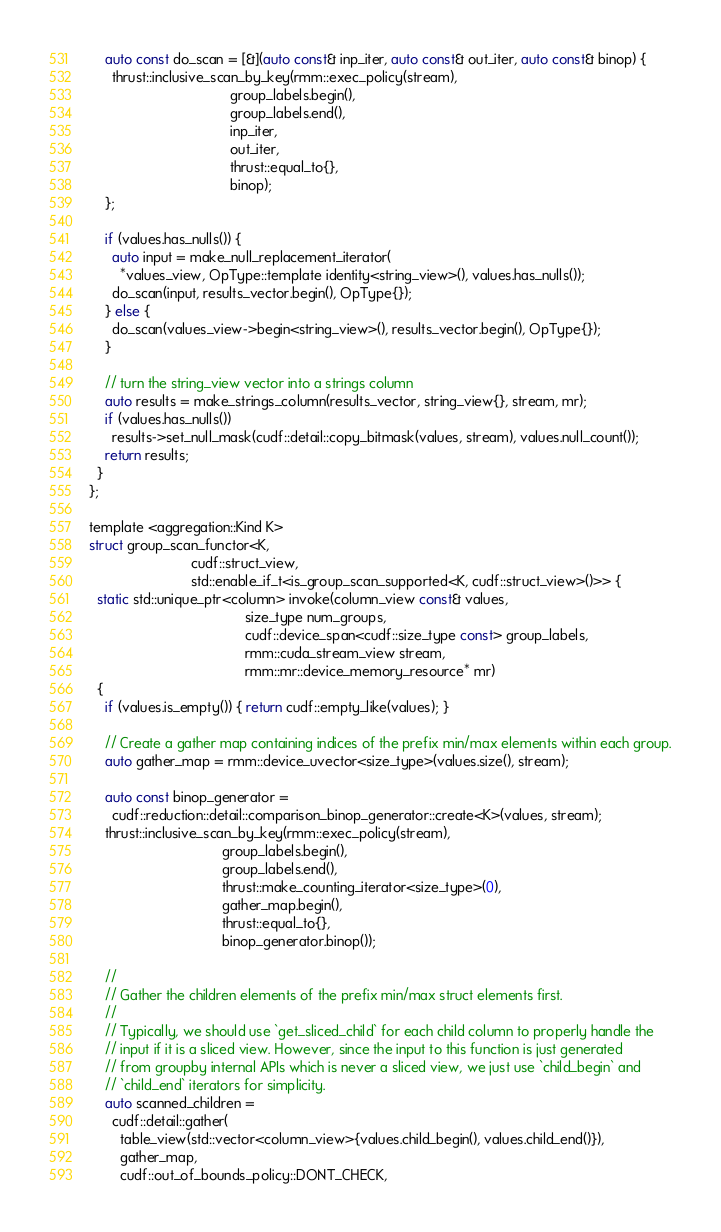Convert code to text. <code><loc_0><loc_0><loc_500><loc_500><_Cuda_>    auto const do_scan = [&](auto const& inp_iter, auto const& out_iter, auto const& binop) {
      thrust::inclusive_scan_by_key(rmm::exec_policy(stream),
                                    group_labels.begin(),
                                    group_labels.end(),
                                    inp_iter,
                                    out_iter,
                                    thrust::equal_to{},
                                    binop);
    };

    if (values.has_nulls()) {
      auto input = make_null_replacement_iterator(
        *values_view, OpType::template identity<string_view>(), values.has_nulls());
      do_scan(input, results_vector.begin(), OpType{});
    } else {
      do_scan(values_view->begin<string_view>(), results_vector.begin(), OpType{});
    }

    // turn the string_view vector into a strings column
    auto results = make_strings_column(results_vector, string_view{}, stream, mr);
    if (values.has_nulls())
      results->set_null_mask(cudf::detail::copy_bitmask(values, stream), values.null_count());
    return results;
  }
};

template <aggregation::Kind K>
struct group_scan_functor<K,
                          cudf::struct_view,
                          std::enable_if_t<is_group_scan_supported<K, cudf::struct_view>()>> {
  static std::unique_ptr<column> invoke(column_view const& values,
                                        size_type num_groups,
                                        cudf::device_span<cudf::size_type const> group_labels,
                                        rmm::cuda_stream_view stream,
                                        rmm::mr::device_memory_resource* mr)
  {
    if (values.is_empty()) { return cudf::empty_like(values); }

    // Create a gather map containing indices of the prefix min/max elements within each group.
    auto gather_map = rmm::device_uvector<size_type>(values.size(), stream);

    auto const binop_generator =
      cudf::reduction::detail::comparison_binop_generator::create<K>(values, stream);
    thrust::inclusive_scan_by_key(rmm::exec_policy(stream),
                                  group_labels.begin(),
                                  group_labels.end(),
                                  thrust::make_counting_iterator<size_type>(0),
                                  gather_map.begin(),
                                  thrust::equal_to{},
                                  binop_generator.binop());

    //
    // Gather the children elements of the prefix min/max struct elements first.
    //
    // Typically, we should use `get_sliced_child` for each child column to properly handle the
    // input if it is a sliced view. However, since the input to this function is just generated
    // from groupby internal APIs which is never a sliced view, we just use `child_begin` and
    // `child_end` iterators for simplicity.
    auto scanned_children =
      cudf::detail::gather(
        table_view(std::vector<column_view>{values.child_begin(), values.child_end()}),
        gather_map,
        cudf::out_of_bounds_policy::DONT_CHECK,</code> 